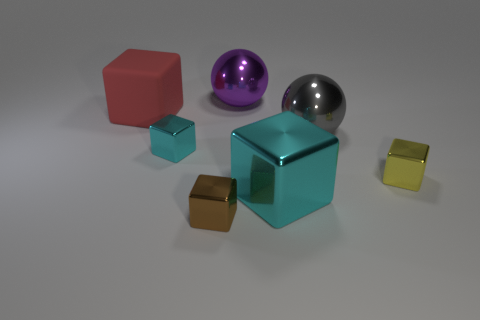Is the shape of the large thing that is on the right side of the large cyan cube the same as  the large purple shiny thing?
Ensure brevity in your answer.  Yes. Is the number of gray things that are behind the small cyan metallic block greater than the number of large purple blocks?
Offer a terse response. Yes. How many objects are both to the left of the yellow metal block and right of the big red object?
Keep it short and to the point. 5. There is a large object in front of the tiny metallic block that is on the left side of the brown metallic object; what color is it?
Make the answer very short. Cyan. What number of small shiny blocks have the same color as the large rubber block?
Offer a terse response. 0. Does the big shiny cube have the same color as the metal thing that is on the left side of the small brown metal cube?
Your answer should be compact. Yes. Are there fewer cubes than large cyan objects?
Provide a succinct answer. No. Is the number of large objects right of the red thing greater than the number of small metallic objects that are to the right of the big cyan thing?
Give a very brief answer. Yes. Is the purple thing made of the same material as the yellow cube?
Ensure brevity in your answer.  Yes. What number of gray things are in front of the big metallic object that is behind the large matte thing?
Offer a very short reply. 1. 